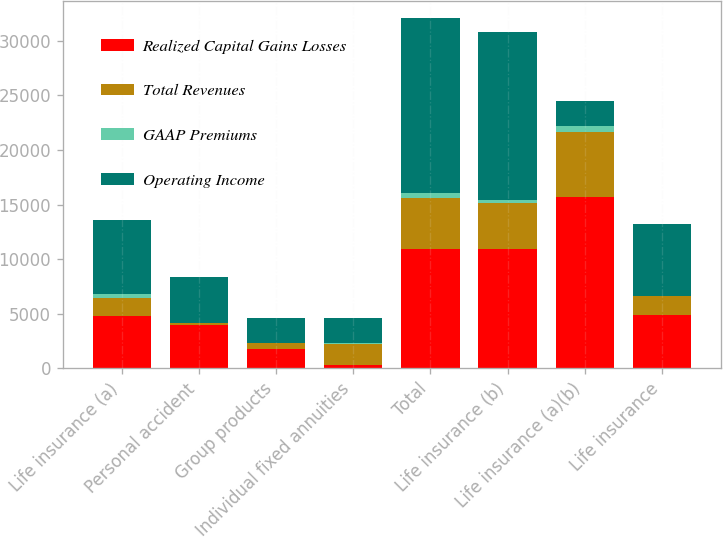Convert chart to OTSL. <chart><loc_0><loc_0><loc_500><loc_500><stacked_bar_chart><ecel><fcel>Life insurance (a)<fcel>Personal accident<fcel>Group products<fcel>Individual fixed annuities<fcel>Total<fcel>Life insurance (b)<fcel>Life insurance (a)(b)<fcel>Life insurance<nl><fcel>Realized Capital Gains Losses<fcel>4769<fcel>3957<fcel>1740<fcel>337<fcel>10976<fcel>10949<fcel>15718<fcel>4852<nl><fcel>Total Revenues<fcel>1696<fcel>162<fcel>541<fcel>1930<fcel>4654<fcel>4188<fcel>5884<fcel>1752<nl><fcel>GAAP Premiums<fcel>316<fcel>49<fcel>13<fcel>28<fcel>406<fcel>258<fcel>574<fcel>52<nl><fcel>Operating Income<fcel>6781<fcel>4168<fcel>2294<fcel>2295<fcel>16036<fcel>15395<fcel>2294<fcel>6552<nl></chart> 